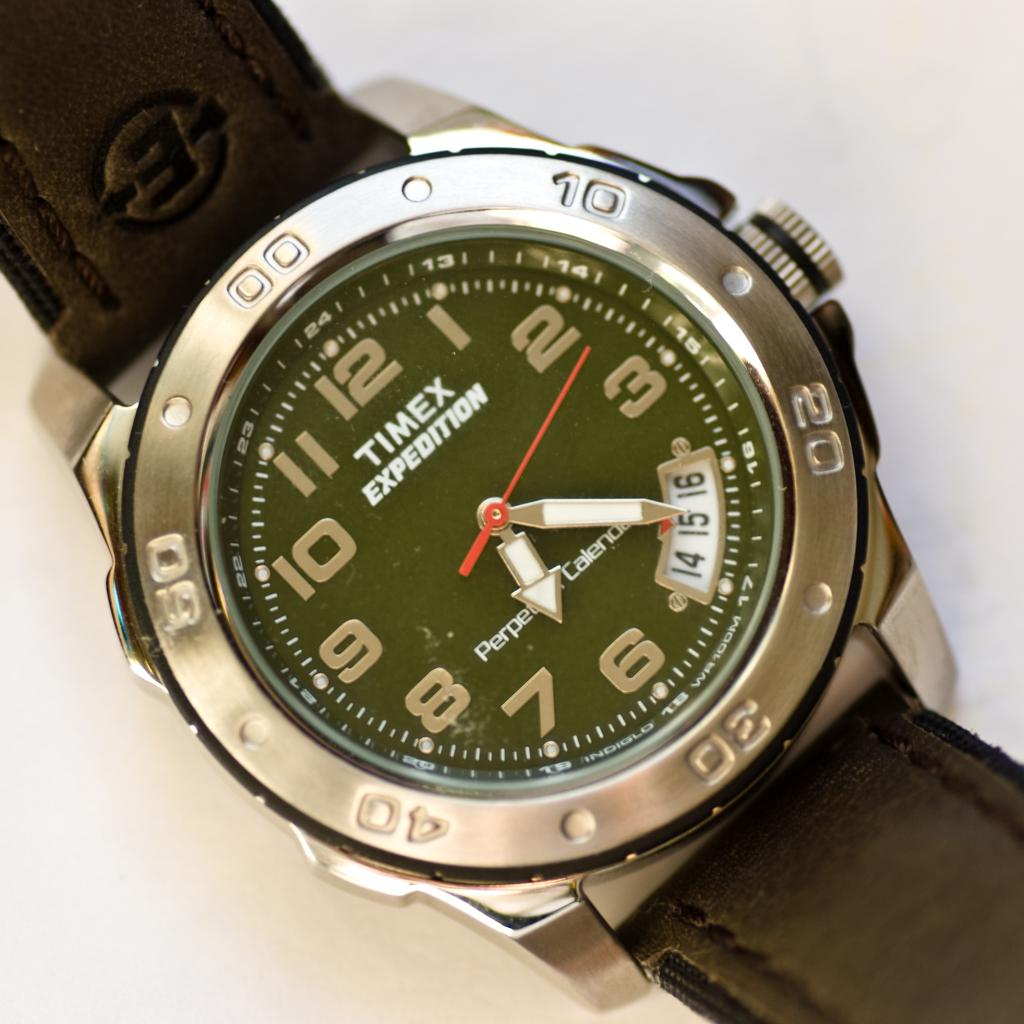<image>
Write a terse but informative summary of the picture. A silver and black Timex Expedition Watch set to 6:20. 